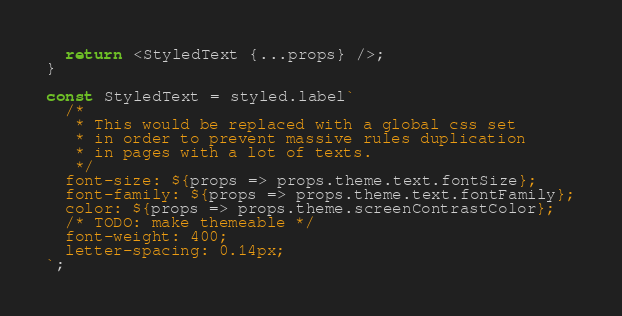Convert code to text. <code><loc_0><loc_0><loc_500><loc_500><_TypeScript_>  return <StyledText {...props} />;
}

const StyledText = styled.label`
  /*
   * This would be replaced with a global css set
   * in order to prevent massive rules duplication
   * in pages with a lot of texts.
   */
  font-size: ${props => props.theme.text.fontSize};
  font-family: ${props => props.theme.text.fontFamily};
  color: ${props => props.theme.screenContrastColor};
  /* TODO: make themeable */
  font-weight: 400;
  letter-spacing: 0.14px;
`;
</code> 